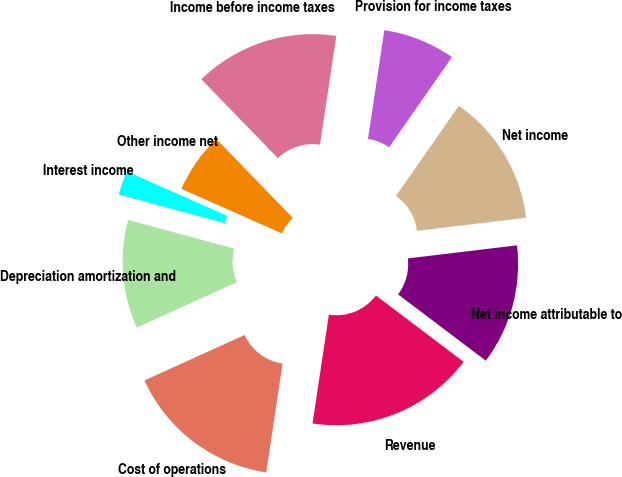<chart> <loc_0><loc_0><loc_500><loc_500><pie_chart><fcel>Revenue<fcel>Cost of operations<fcel>Depreciation amortization and<fcel>Interest income<fcel>Other income net<fcel>Income before income taxes<fcel>Provision for income taxes<fcel>Net income<fcel>Net income attributable to<nl><fcel>17.07%<fcel>15.85%<fcel>10.98%<fcel>2.44%<fcel>6.1%<fcel>14.63%<fcel>7.32%<fcel>13.41%<fcel>12.2%<nl></chart> 